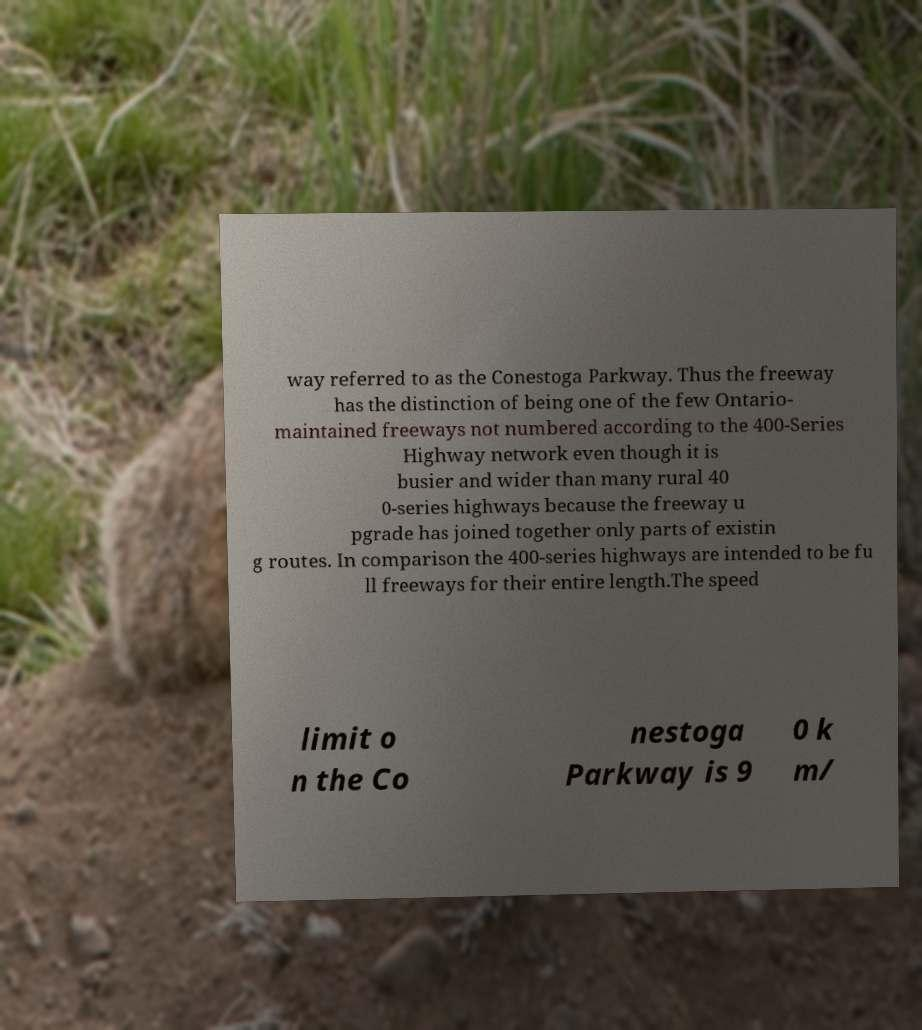Can you read and provide the text displayed in the image?This photo seems to have some interesting text. Can you extract and type it out for me? way referred to as the Conestoga Parkway. Thus the freeway has the distinction of being one of the few Ontario- maintained freeways not numbered according to the 400-Series Highway network even though it is busier and wider than many rural 40 0-series highways because the freeway u pgrade has joined together only parts of existin g routes. In comparison the 400-series highways are intended to be fu ll freeways for their entire length.The speed limit o n the Co nestoga Parkway is 9 0 k m/ 